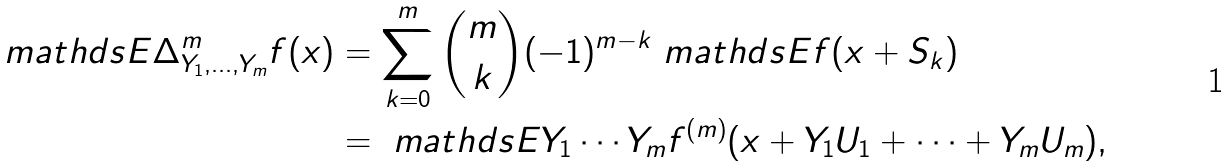Convert formula to latex. <formula><loc_0><loc_0><loc_500><loc_500>\ m a t h d s { E } \Delta ^ { m } _ { Y _ { 1 } , \dots , Y _ { m } } f ( x ) & = \sum _ { k = 0 } ^ { m } \binom { m } { k } ( - 1 ) ^ { m - k } \ m a t h d s { E } f ( x + S _ { k } ) \\ & = \ m a t h d s { E } Y _ { 1 } \cdots Y _ { m } f ^ { ( m ) } ( x + Y _ { 1 } U _ { 1 } + \cdots + Y _ { m } U _ { m } ) ,</formula> 